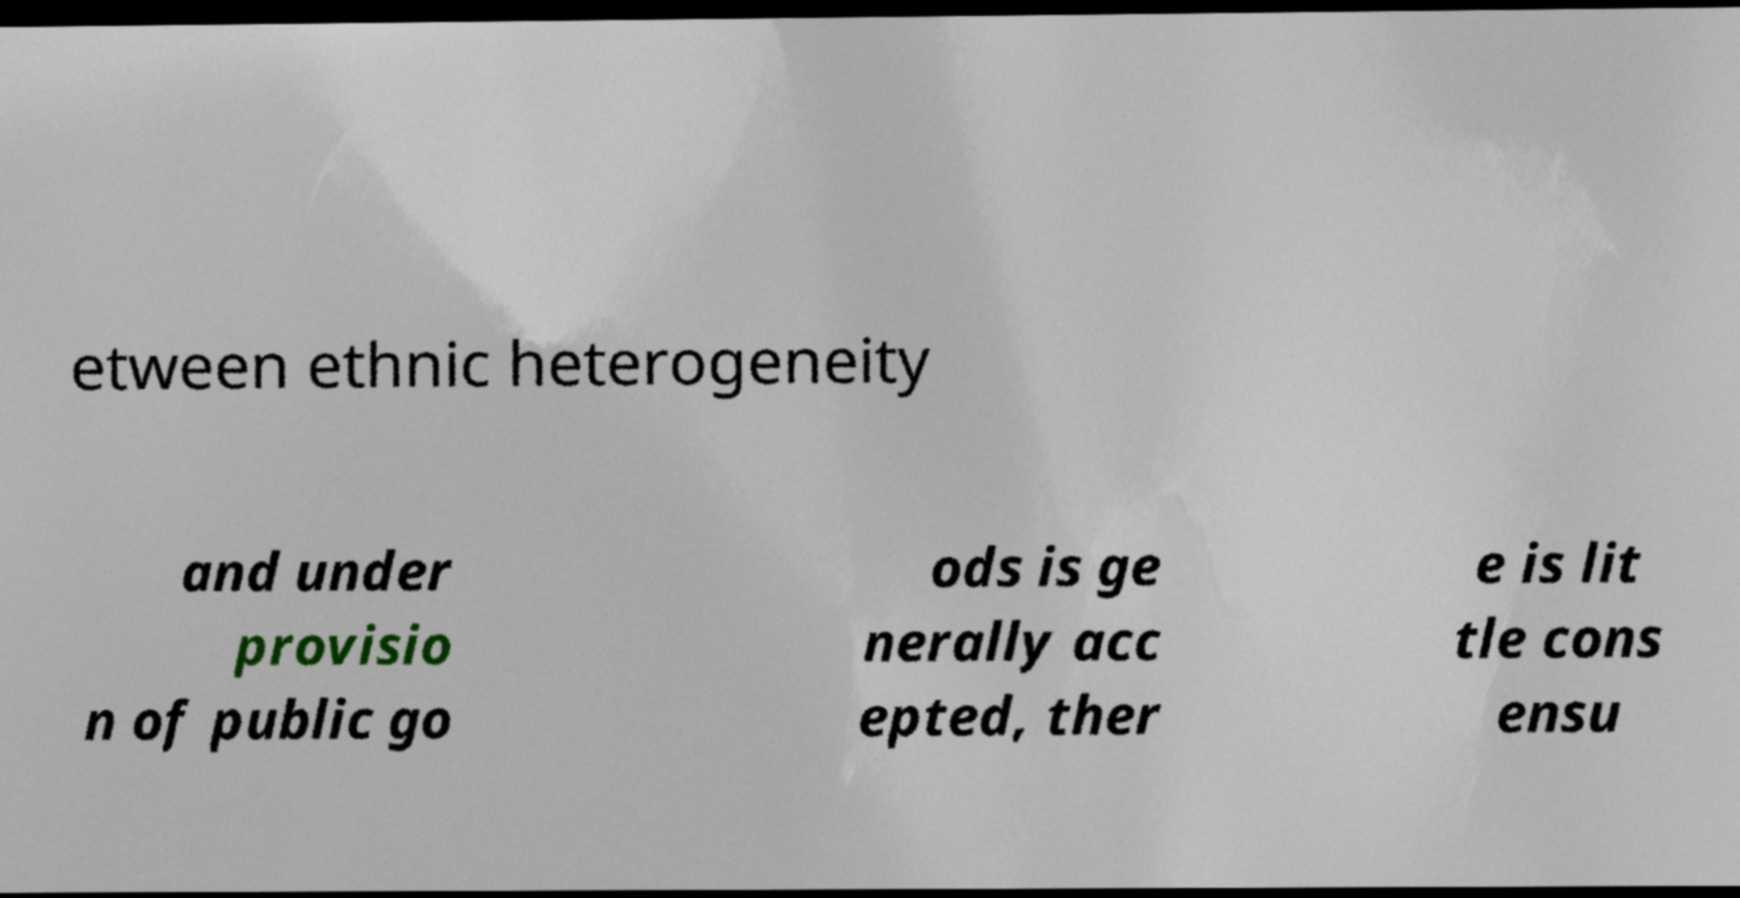What messages or text are displayed in this image? I need them in a readable, typed format. etween ethnic heterogeneity and under provisio n of public go ods is ge nerally acc epted, ther e is lit tle cons ensu 